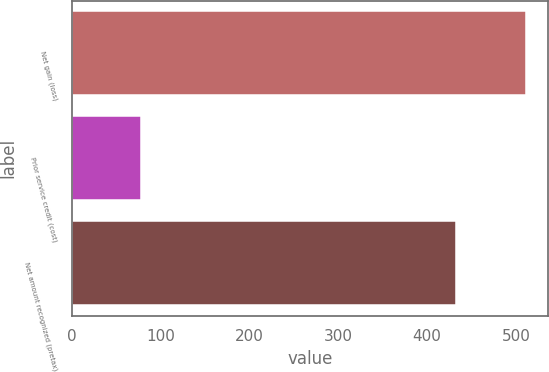Convert chart. <chart><loc_0><loc_0><loc_500><loc_500><bar_chart><fcel>Net gain (loss)<fcel>Prior service credit (cost)<fcel>Net amount recognized (pretax)<nl><fcel>511<fcel>78<fcel>433<nl></chart> 